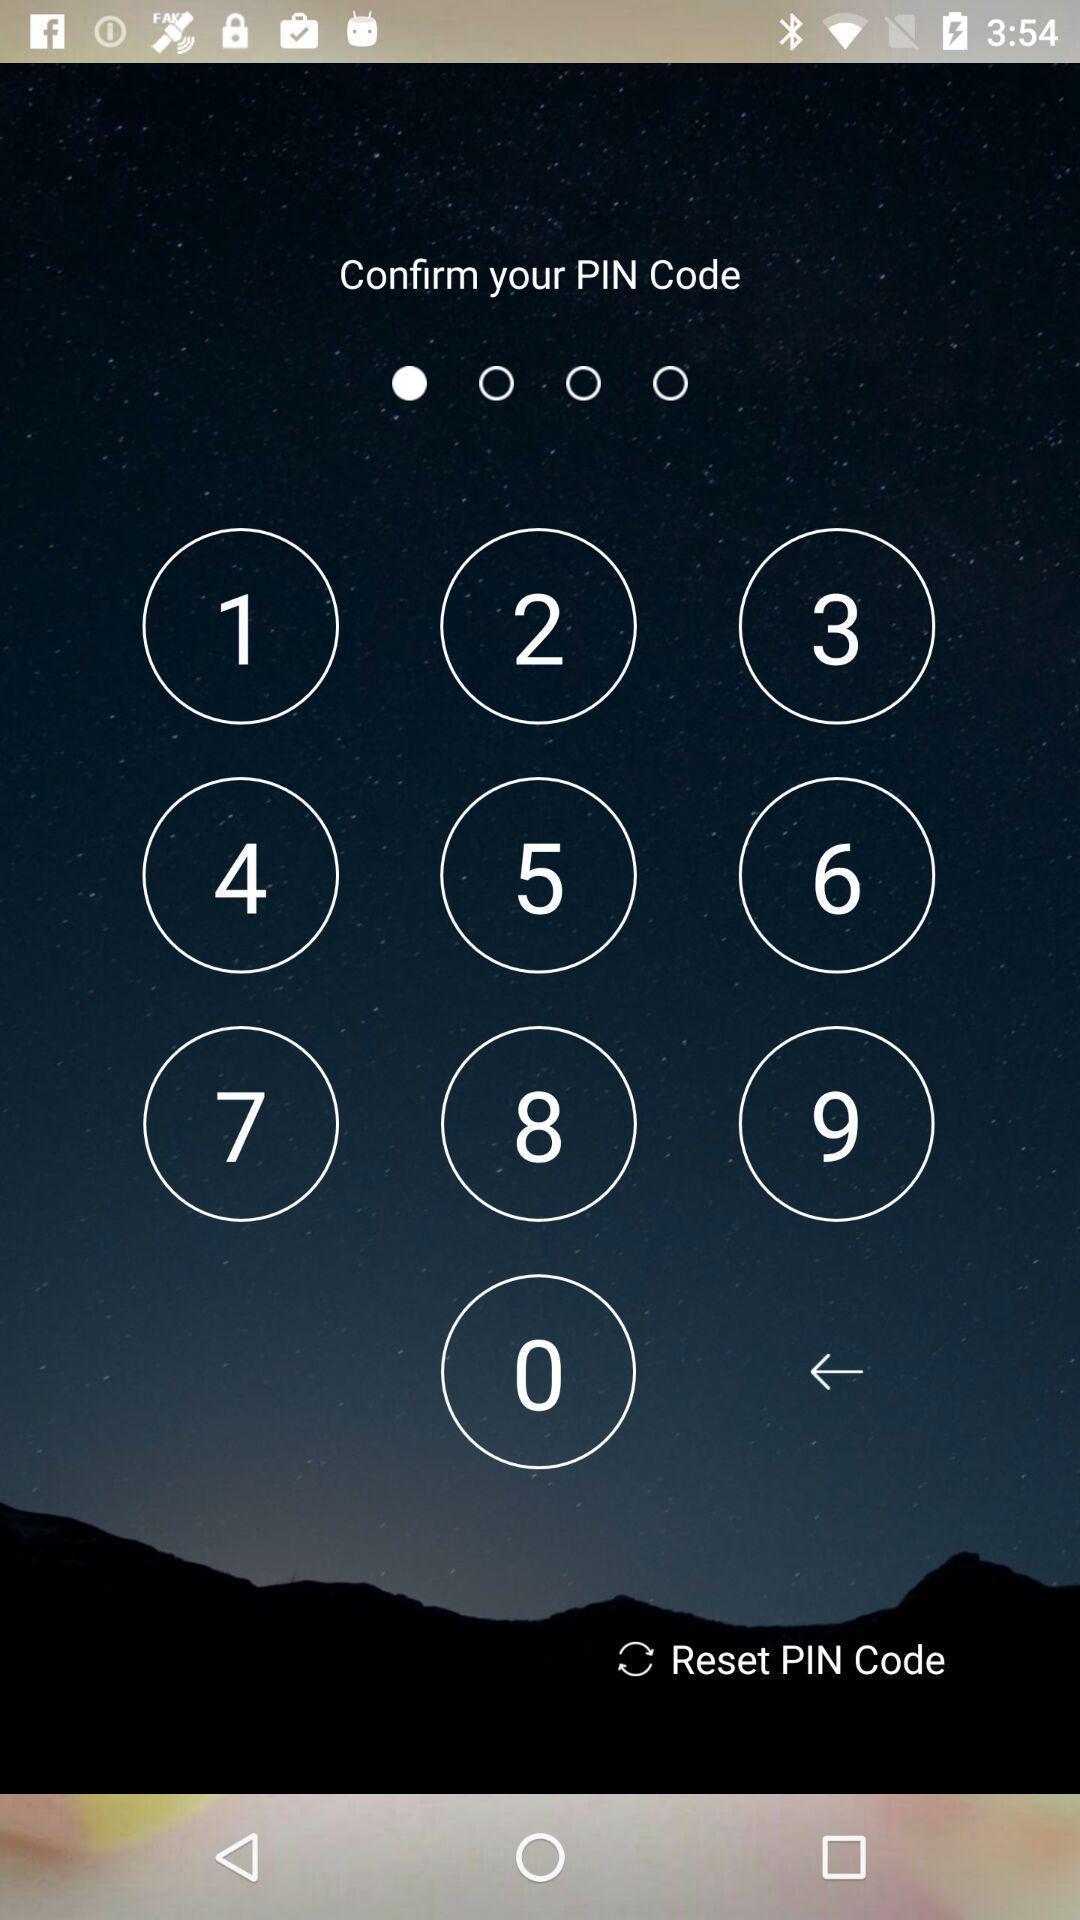What is the overall content of this screenshot? Page to confirm pin code. 